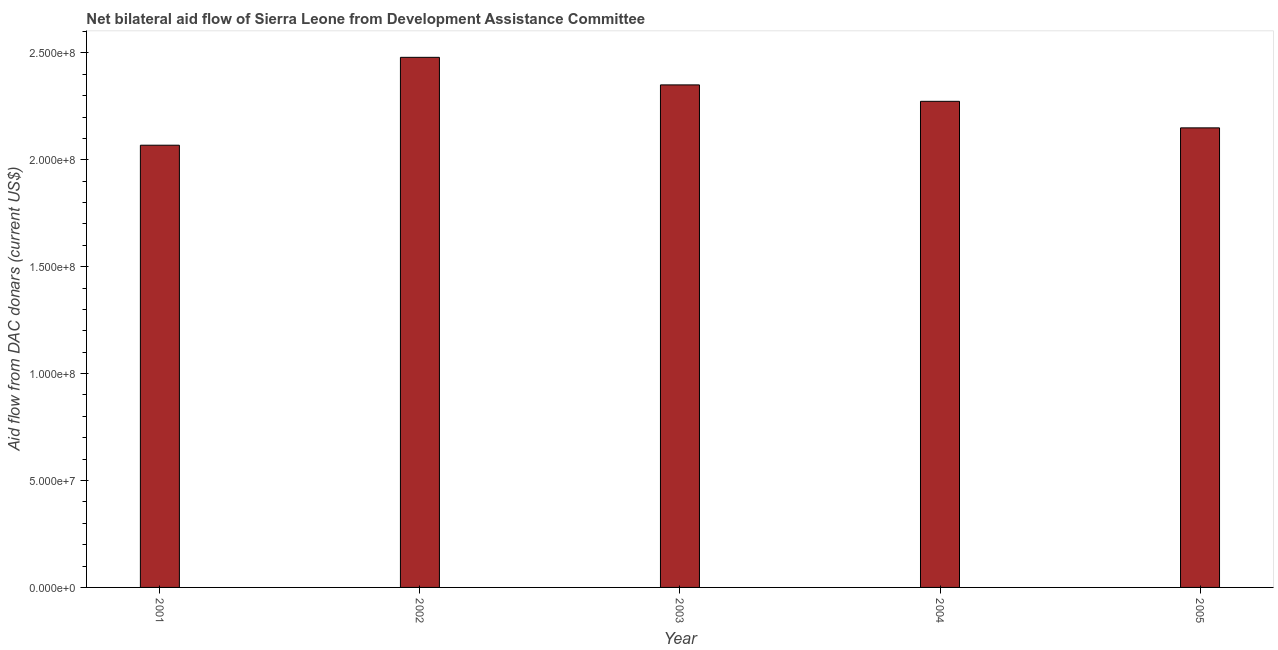Does the graph contain grids?
Offer a terse response. No. What is the title of the graph?
Keep it short and to the point. Net bilateral aid flow of Sierra Leone from Development Assistance Committee. What is the label or title of the X-axis?
Keep it short and to the point. Year. What is the label or title of the Y-axis?
Offer a very short reply. Aid flow from DAC donars (current US$). What is the net bilateral aid flows from dac donors in 2003?
Your response must be concise. 2.35e+08. Across all years, what is the maximum net bilateral aid flows from dac donors?
Provide a succinct answer. 2.48e+08. Across all years, what is the minimum net bilateral aid flows from dac donors?
Your response must be concise. 2.07e+08. In which year was the net bilateral aid flows from dac donors maximum?
Provide a succinct answer. 2002. In which year was the net bilateral aid flows from dac donors minimum?
Offer a terse response. 2001. What is the sum of the net bilateral aid flows from dac donors?
Offer a terse response. 1.13e+09. What is the difference between the net bilateral aid flows from dac donors in 2003 and 2005?
Your answer should be compact. 2.01e+07. What is the average net bilateral aid flows from dac donors per year?
Offer a terse response. 2.26e+08. What is the median net bilateral aid flows from dac donors?
Make the answer very short. 2.27e+08. In how many years, is the net bilateral aid flows from dac donors greater than 110000000 US$?
Your response must be concise. 5. Do a majority of the years between 2003 and 2005 (inclusive) have net bilateral aid flows from dac donors greater than 250000000 US$?
Provide a succinct answer. No. What is the ratio of the net bilateral aid flows from dac donors in 2002 to that in 2004?
Give a very brief answer. 1.09. Is the net bilateral aid flows from dac donors in 2003 less than that in 2004?
Provide a succinct answer. No. What is the difference between the highest and the second highest net bilateral aid flows from dac donors?
Your answer should be very brief. 1.29e+07. What is the difference between the highest and the lowest net bilateral aid flows from dac donors?
Your answer should be compact. 4.11e+07. In how many years, is the net bilateral aid flows from dac donors greater than the average net bilateral aid flows from dac donors taken over all years?
Your answer should be compact. 3. Are all the bars in the graph horizontal?
Offer a terse response. No. How many years are there in the graph?
Give a very brief answer. 5. What is the difference between two consecutive major ticks on the Y-axis?
Offer a terse response. 5.00e+07. What is the Aid flow from DAC donars (current US$) in 2001?
Your answer should be very brief. 2.07e+08. What is the Aid flow from DAC donars (current US$) in 2002?
Ensure brevity in your answer.  2.48e+08. What is the Aid flow from DAC donars (current US$) in 2003?
Your answer should be compact. 2.35e+08. What is the Aid flow from DAC donars (current US$) in 2004?
Your answer should be compact. 2.27e+08. What is the Aid flow from DAC donars (current US$) in 2005?
Keep it short and to the point. 2.15e+08. What is the difference between the Aid flow from DAC donars (current US$) in 2001 and 2002?
Ensure brevity in your answer.  -4.11e+07. What is the difference between the Aid flow from DAC donars (current US$) in 2001 and 2003?
Offer a terse response. -2.82e+07. What is the difference between the Aid flow from DAC donars (current US$) in 2001 and 2004?
Offer a very short reply. -2.05e+07. What is the difference between the Aid flow from DAC donars (current US$) in 2001 and 2005?
Keep it short and to the point. -8.11e+06. What is the difference between the Aid flow from DAC donars (current US$) in 2002 and 2003?
Make the answer very short. 1.29e+07. What is the difference between the Aid flow from DAC donars (current US$) in 2002 and 2004?
Provide a succinct answer. 2.06e+07. What is the difference between the Aid flow from DAC donars (current US$) in 2002 and 2005?
Provide a succinct answer. 3.30e+07. What is the difference between the Aid flow from DAC donars (current US$) in 2003 and 2004?
Make the answer very short. 7.68e+06. What is the difference between the Aid flow from DAC donars (current US$) in 2003 and 2005?
Your answer should be very brief. 2.01e+07. What is the difference between the Aid flow from DAC donars (current US$) in 2004 and 2005?
Ensure brevity in your answer.  1.24e+07. What is the ratio of the Aid flow from DAC donars (current US$) in 2001 to that in 2002?
Give a very brief answer. 0.83. What is the ratio of the Aid flow from DAC donars (current US$) in 2001 to that in 2003?
Your answer should be compact. 0.88. What is the ratio of the Aid flow from DAC donars (current US$) in 2001 to that in 2004?
Provide a succinct answer. 0.91. What is the ratio of the Aid flow from DAC donars (current US$) in 2002 to that in 2003?
Provide a short and direct response. 1.05. What is the ratio of the Aid flow from DAC donars (current US$) in 2002 to that in 2004?
Ensure brevity in your answer.  1.09. What is the ratio of the Aid flow from DAC donars (current US$) in 2002 to that in 2005?
Ensure brevity in your answer.  1.15. What is the ratio of the Aid flow from DAC donars (current US$) in 2003 to that in 2004?
Offer a very short reply. 1.03. What is the ratio of the Aid flow from DAC donars (current US$) in 2003 to that in 2005?
Give a very brief answer. 1.09. What is the ratio of the Aid flow from DAC donars (current US$) in 2004 to that in 2005?
Provide a succinct answer. 1.06. 